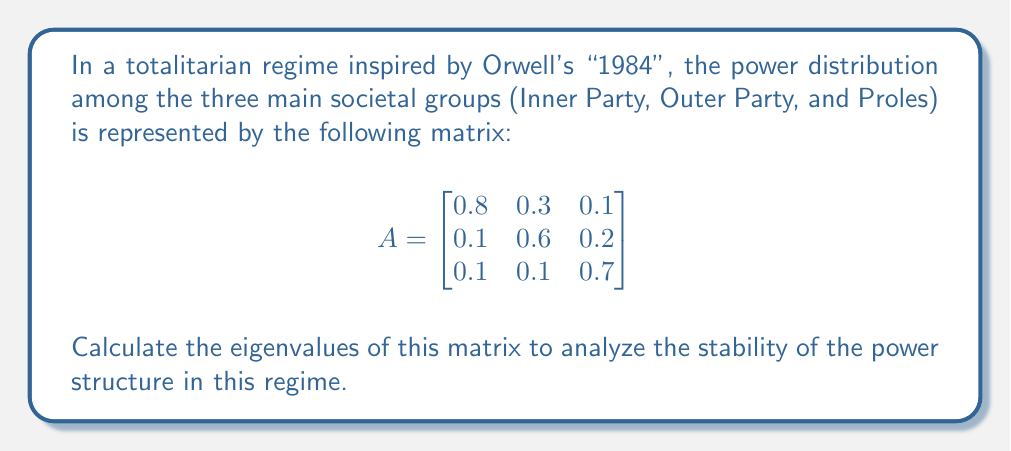Can you answer this question? To find the eigenvalues of matrix $A$, we need to solve the characteristic equation:

$$\det(A - \lambda I) = 0$$

Where $I$ is the $3 \times 3$ identity matrix and $\lambda$ represents the eigenvalues.

Step 1: Set up the characteristic equation:

$$\det\begin{bmatrix}
0.8 - \lambda & 0.3 & 0.1 \\
0.1 & 0.6 - \lambda & 0.2 \\
0.1 & 0.1 & 0.7 - \lambda
\end{bmatrix} = 0$$

Step 2: Expand the determinant:

$$(0.8 - \lambda)[(0.6 - \lambda)(0.7 - \lambda) - 0.02] - 0.3[0.1(0.7 - \lambda) - 0.02] + 0.1[0.1(0.6 - \lambda) - 0.02] = 0$$

Step 3: Simplify:

$$-\lambda^3 + 2.1\lambda^2 - 1.41\lambda + 0.3 = 0$$

Step 4: Solve the cubic equation. This can be done using the cubic formula or numerical methods. Using a computer algebra system, we find the roots:

$$\lambda_1 \approx 1, \lambda_2 \approx 0.7, \lambda_3 \approx 0.4$$

These eigenvalues represent the long-term power distribution in the regime. The largest eigenvalue (1) indicates the dominant power group, likely the Inner Party in this Orwellian scenario.
Answer: The eigenvalues of the matrix are approximately:
$\lambda_1 \approx 1$
$\lambda_2 \approx 0.7$
$\lambda_3 \approx 0.4$ 